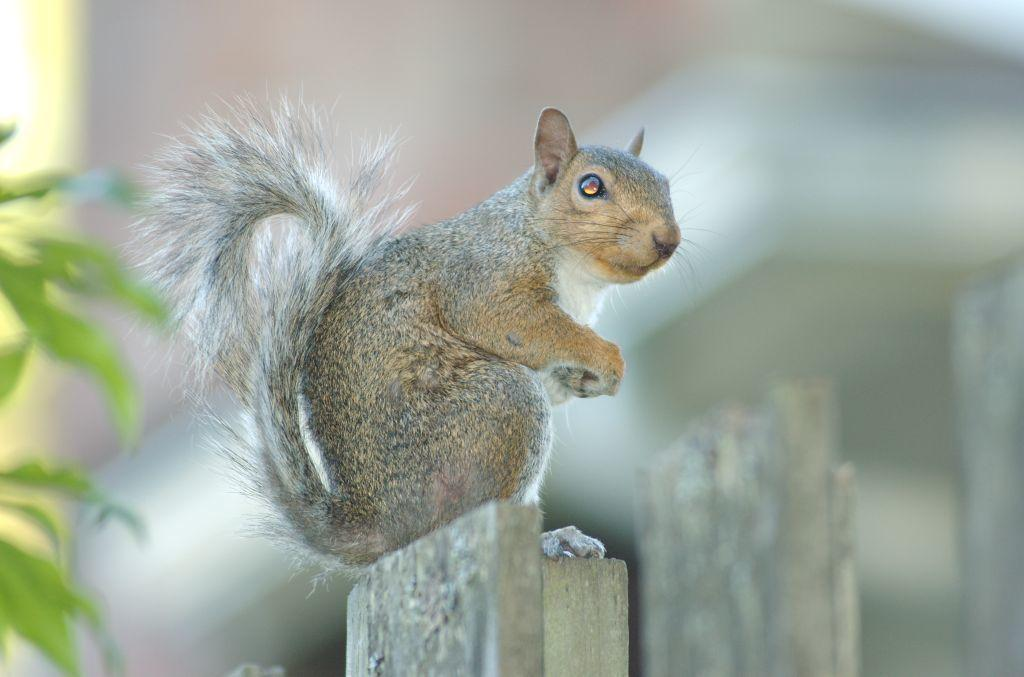What animal can be seen in the image? There is a squirrel in the image. Where is the squirrel located? The squirrel is sitting on a wooden pole. What else is present in the image besides the squirrel? There is a plant in the image. What type of lock is the squirrel using to secure the plant in the image? There is no lock present in the image, and the squirrel is not securing the plant. 